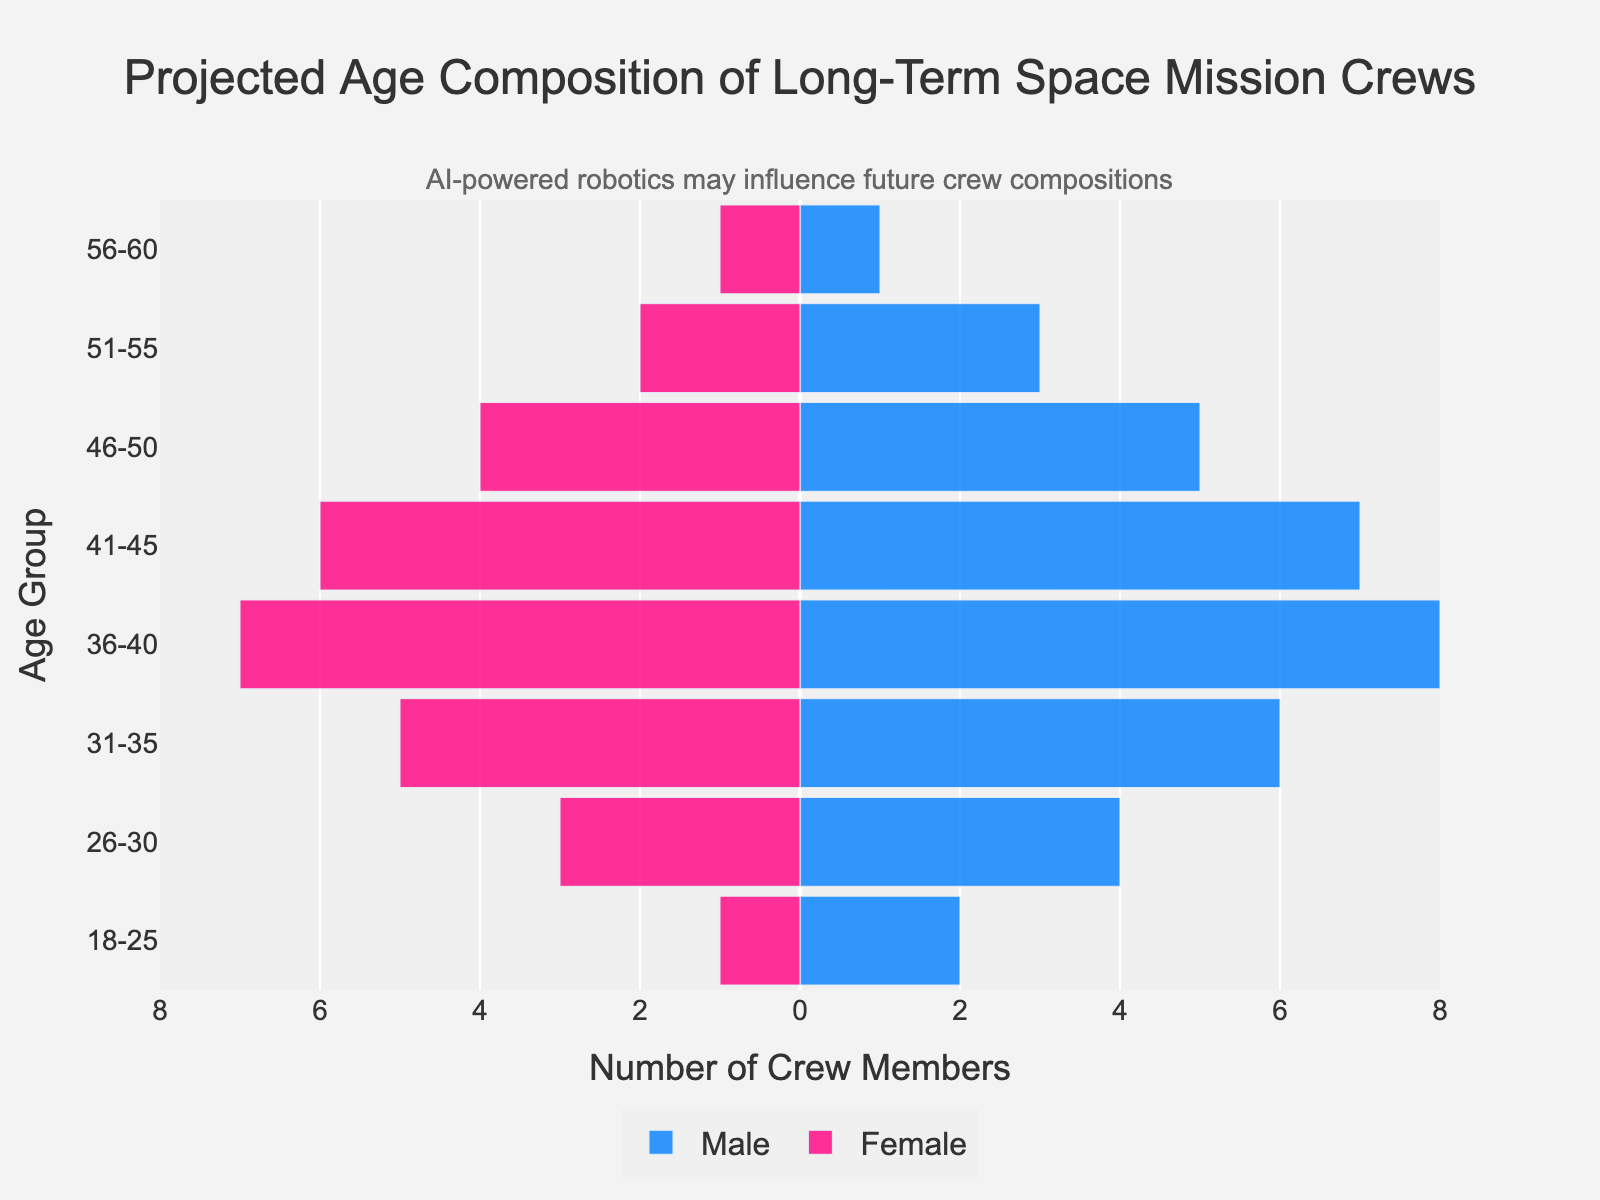What is the highest number of male crew members in any age group? The figure indicates that the age group 36-40 has the highest number of male crew members, with the bar extending to 8.
Answer: 8 How many female crew members are there in the 41-45 age group? The figure shows that the female bar for the 41-45 age group extends to -6, indicating 6 female crew members.
Answer: 6 What is the total number of crew members in the 46-50 age group? The figure shows 5 male crew members and 4 female crew members in the 46-50 age group. Adding these together gives a total of 9 crew members.
Answer: 9 Which age group has an equal number of male and female crew members? The figure shows that the age group 56-60 has 1 male and 1 female crew member, indicated by bars extending to both 1 and -1, and thus has an equal number.
Answer: 56-60 Compare the number of male and female crew members in the 31-35 age group. The figure shows that there are 6 male crew members and 5 female crew members in the 31-35 age group, with the male bar extending to 6 and the female bar to -5. Therefore, there is one more male.
Answer: 1 more male In which age group is the difference between the number of male and female crew members the greatest? In the age group 36-40, the figure shows 8 male crew members and 7 female crew members. The difference is 1, which is the greatest difference amongst all the age groups.
Answer: 36-40 What is the average number of crew members aged 18-25? The figure shows 2 male and 1 female crew members in the 18-25 age group. To find the average: (2 + 1) / 2 = 1.5.
Answer: 1.5 Compare the number of crew members in the 26-30 and 51-55 age groups. The figure shows 7 crew members (4 males, 3 females) in the 26-30 age group and 5 crew members (3 males, 2 females) in the 51-55 age group. Hence, the 26-30 group has 2 more crew members than the 51-55 age group.
Answer: 2 more in 26-30 Are there more crew members above or below the age of 40? Summing up the crew members above 40 (total from age groups 41-60 provides these values: 13 + 9 + 5 + 2 = 29) and below 40 (total from age groups 18-40 provides these values: 3 + 7 + 11 + 15 = 36), it's evident that there are more crew members below 40.
Answer: More below 40 How might AI-powered robotics influence the age composition of future space mission crews? While the figure explicitly does not define this, it annotates that AI-powered robotics might lead to a more balanced or younger age composition, highlighting potential changes due to technological assistance.
Answer: Balanced/Younger crews 